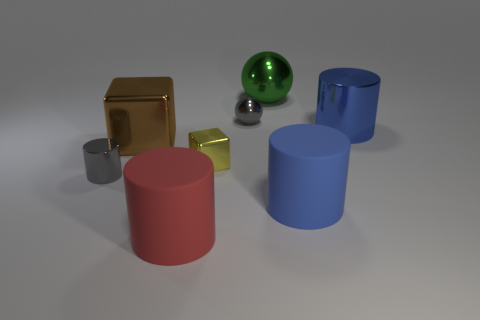What is the color of the big block that is the same material as the big sphere?
Your answer should be compact. Brown. How many big red things are made of the same material as the small yellow thing?
Your response must be concise. 0. Do the gray metal object in front of the small gray ball and the gray object on the right side of the small yellow metal object have the same size?
Your answer should be compact. Yes. What material is the big brown object in front of the ball that is to the left of the big sphere made of?
Your answer should be very brief. Metal. Is the number of big cylinders that are to the right of the green metal object less than the number of tiny gray cylinders that are behind the tiny gray metallic ball?
Keep it short and to the point. No. What is the material of the sphere that is the same color as the small cylinder?
Offer a terse response. Metal. Are there any other things that are the same shape as the large brown thing?
Provide a succinct answer. Yes. What material is the big blue cylinder that is in front of the big blue metal object?
Provide a succinct answer. Rubber. Is there anything else that is the same size as the yellow shiny object?
Your response must be concise. Yes. There is a tiny yellow thing; are there any brown cubes right of it?
Your answer should be very brief. No. 